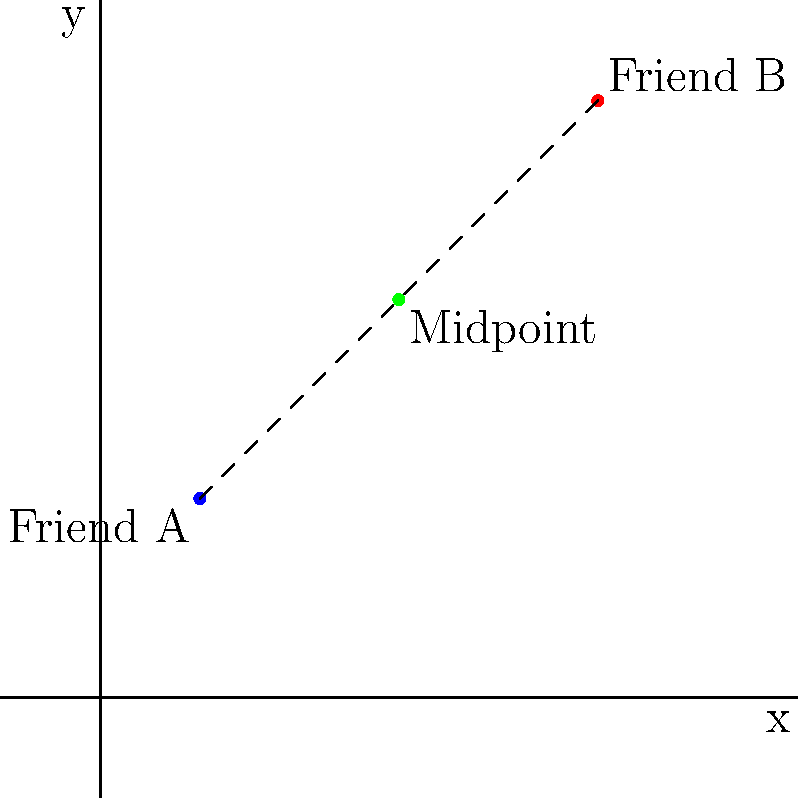On a grid-based social media interface, Friend A's profile picture is located at coordinates (1, 2), while Friend B's profile picture is at (5, 6). What are the coordinates of the midpoint between their profile pictures? To find the midpoint between two points, we use the midpoint formula:

$$ \text{Midpoint} = \left(\frac{x_1 + x_2}{2}, \frac{y_1 + y_2}{2}\right) $$

Where $(x_1, y_1)$ are the coordinates of the first point and $(x_2, y_2)$ are the coordinates of the second point.

For Friend A: $(x_1, y_1) = (1, 2)$
For Friend B: $(x_2, y_2) = (5, 6)$

Let's calculate the x-coordinate of the midpoint:
$$ x = \frac{x_1 + x_2}{2} = \frac{1 + 5}{2} = \frac{6}{2} = 3 $$

Now, let's calculate the y-coordinate of the midpoint:
$$ y = \frac{y_1 + y_2}{2} = \frac{2 + 6}{2} = \frac{8}{2} = 4 $$

Therefore, the midpoint between the two profile pictures is at coordinates (3, 4).
Answer: (3, 4) 